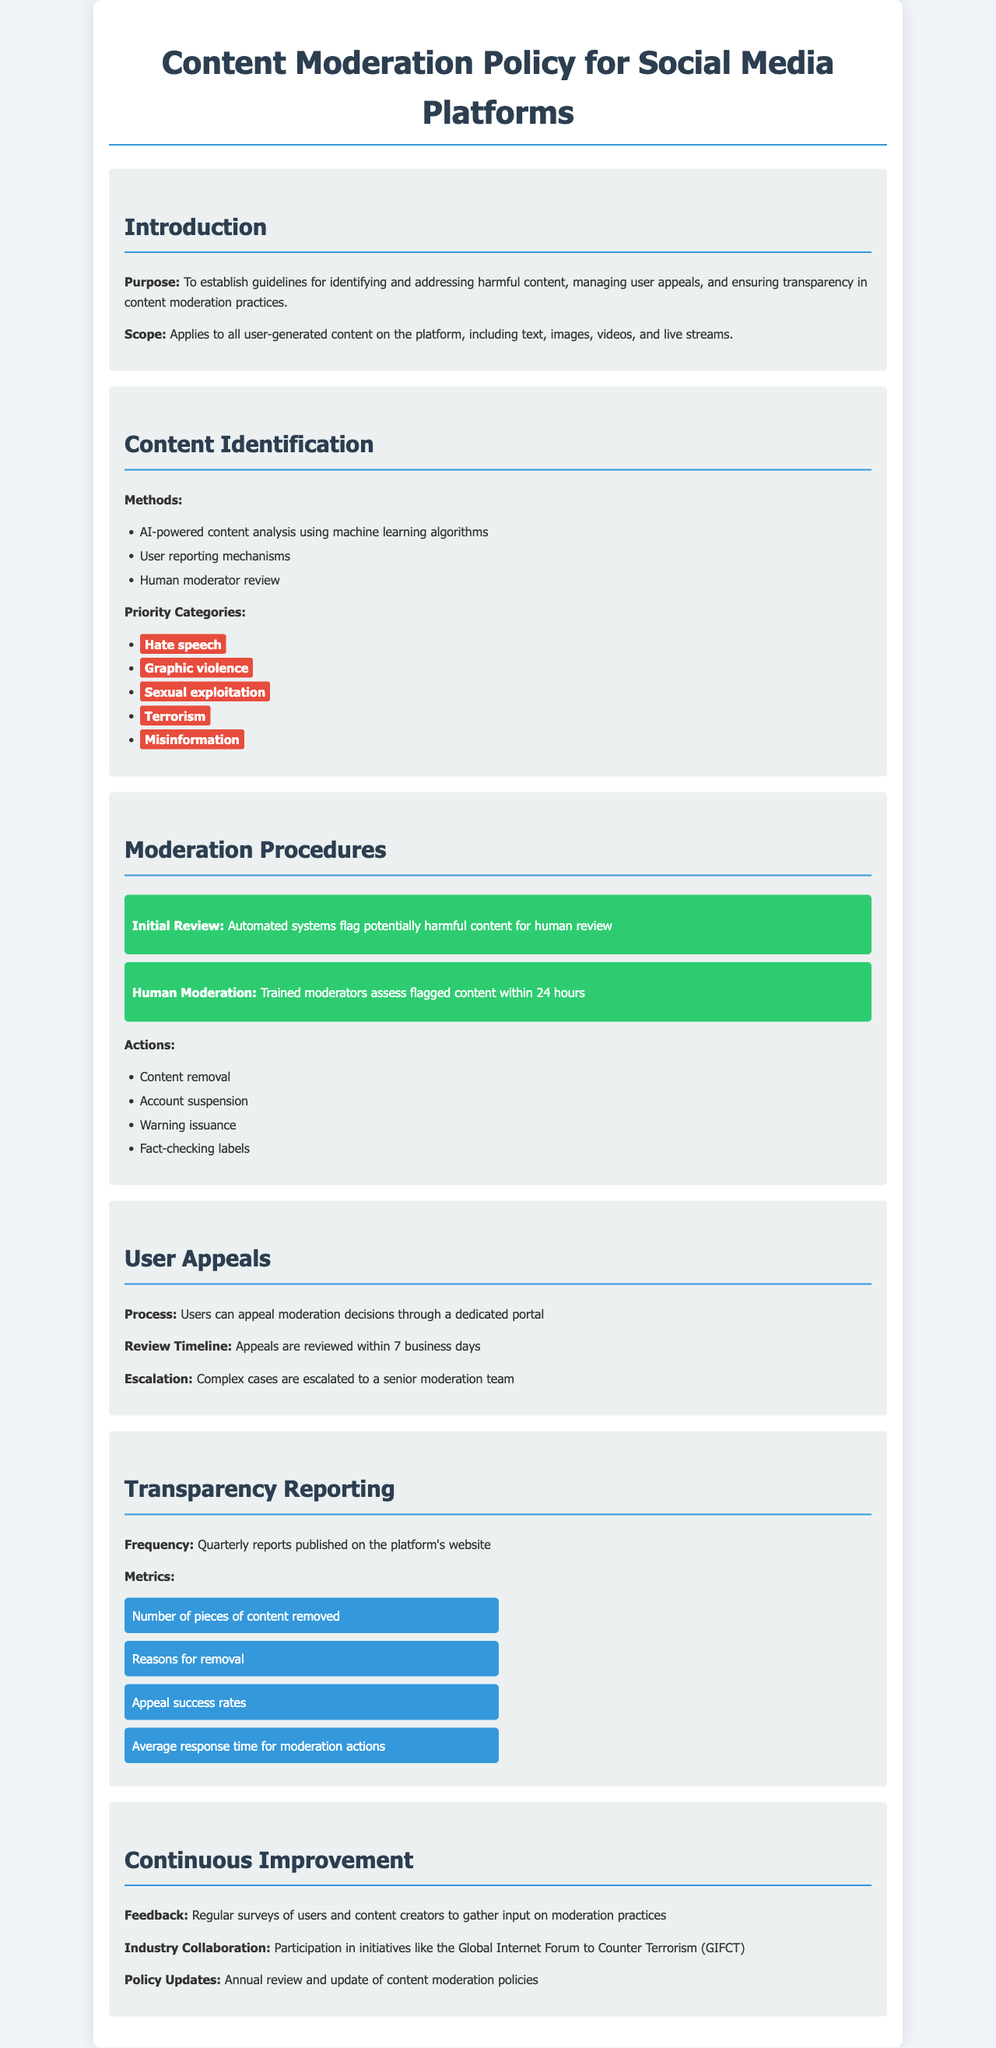What is the purpose of the policy? The purpose is outlined in the introduction of the document, which establishes guidelines for identifying and addressing harmful content, managing user appeals, and ensuring transparency in content moderation practices.
Answer: To establish guidelines for identifying and addressing harmful content, managing user appeals, and ensuring transparency in content moderation practices What are the priority categories for content identification? The priority categories are specifically listed in the Content Identification section and include various types of harmful content.
Answer: Hate speech, Graphic violence, Sexual exploitation, Terrorism, Misinformation How long do users have to wait for an appeal review? The document states the review timeline for appeals in the User Appeals section.
Answer: 7 business days What type of content can users appeal? The document specifies that users can appeal moderation decisions, which typically refers to actions taken against their content.
Answer: Moderation decisions How often are transparency reports published? The frequency of transparency reports is mentioned in the Transparency Reporting section of the document.
Answer: Quarterly What actions can be taken during human moderation? The types of actions are listed in the Moderation Procedures section and include various responses to flagged content.
Answer: Content removal, Account suspension, Warning issuance, Fact-checking labels What feedback method is mentioned for continuous improvement? The Continuous Improvement section describes the process of gathering input to enhance moderation practices.
Answer: Regular surveys What initiative is the policy aligned with for industry collaboration? The document refers to a specific initiative in the Continuous Improvement section that the platform participates in.
Answer: Global Internet Forum to Counter Terrorism (GIFCT) 